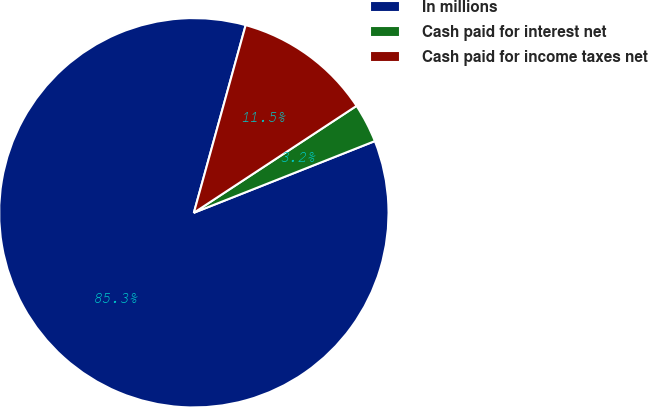Convert chart to OTSL. <chart><loc_0><loc_0><loc_500><loc_500><pie_chart><fcel>In millions<fcel>Cash paid for interest net<fcel>Cash paid for income taxes net<nl><fcel>85.29%<fcel>3.25%<fcel>11.46%<nl></chart> 